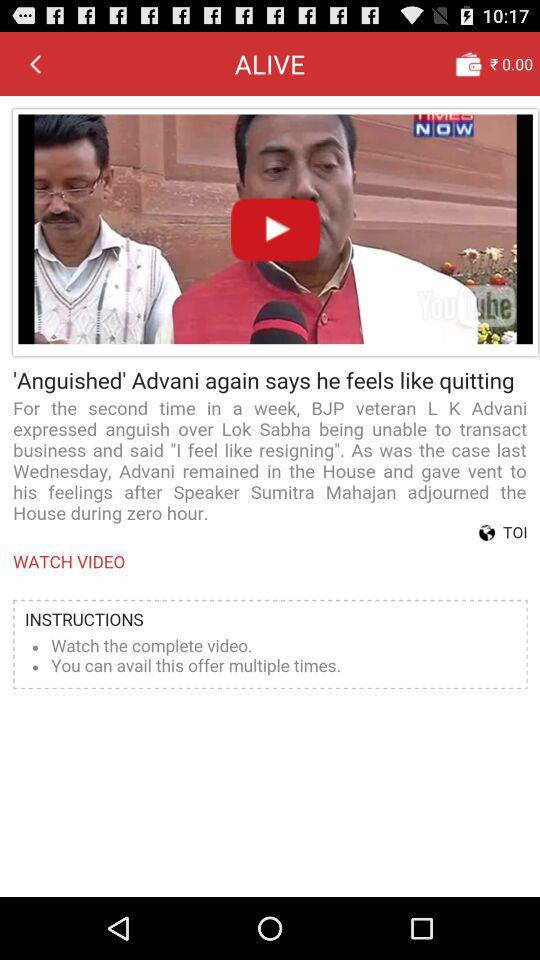What is the wallet balance? The wallet balance is 0 rupees. 